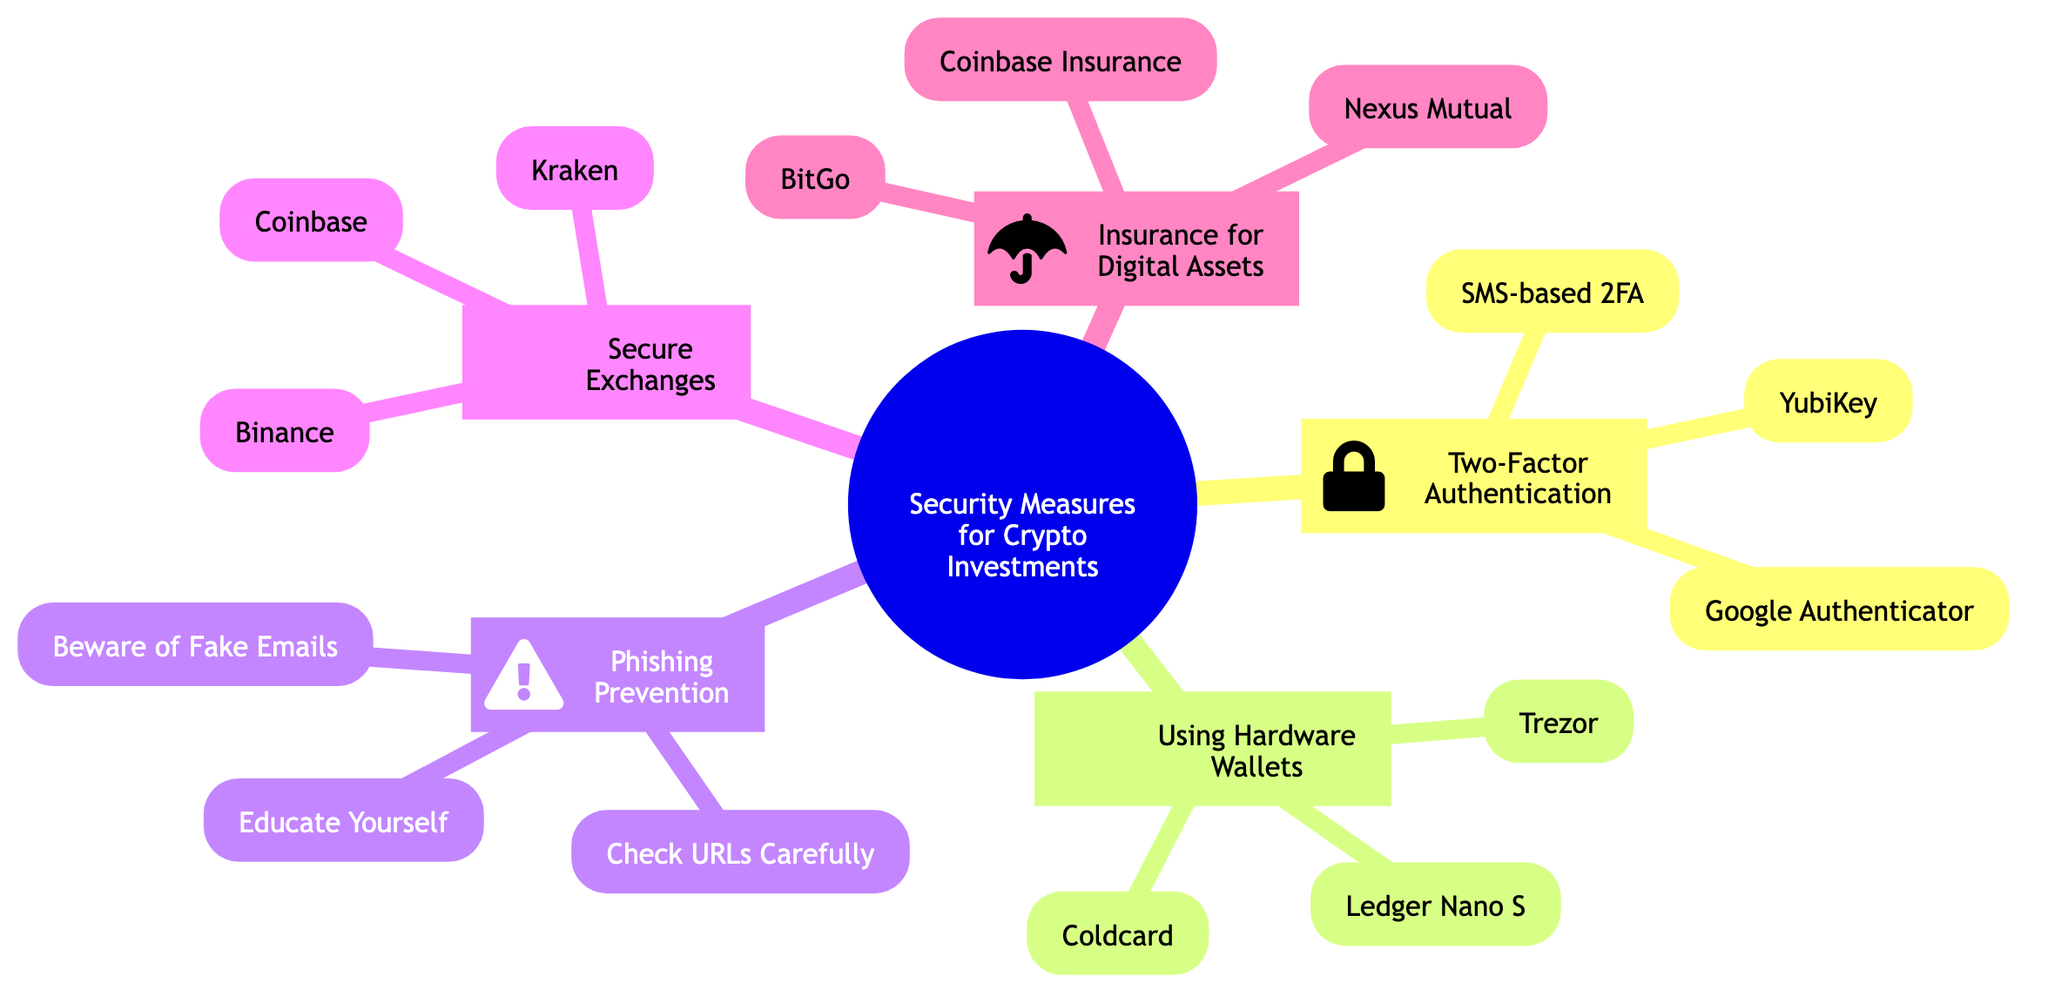What is the main topic of the mind map? The main topic is located at the root of the diagram, clearly labeled as "Security Measures for Crypto Investments." This can be directly read from the diagram, making it easy to identify.
Answer: Security Measures for Crypto Investments How many subtopics are listed under the main topic? The diagram shows five distinct subtopics branching from the main topic. Each subtopic is a separate node connected to the root node, allowing for easy counting.
Answer: 5 What type of authentication is represented by Google Authenticator? In the section "Two-Factor Authentication," Google Authenticator is specifically categorized as an app for two-step verification codes. This is noted directly under the corresponding subtopic in the diagram.
Answer: Two-step verification Which hardware wallet focuses primarily on Bitcoin? Under the "Using Hardware Wallets" subtopic, Coldcard is explicitly mentioned as focusing on Bitcoin and known for high security. This distinction is clearly noted within the provided elements.
Answer: Coldcard What security measure does Coinbase offer for insuring digital assets? In the "Insurance for Digital Assets" section, Coinbase Insurance is mentioned as providing coverage for losses from breaches up to a limit, indicating its specific role. This detail is directly stated in the diagram’s elements.
Answer: Coinbase Insurance What types of phishing prevention are suggested? The section labeled "Phishing Prevention" lists three methods: "Beware of Fake Emails," "Check URLs Carefully," and "Educate Yourself." Each method addresses a specific aspect of phishing prevention, and thus all three are considered as correct answers.
Answer: Beware of Fake Emails, Check URLs Carefully, Educate Yourself Which exchange is known for storing 98% of funds offline? Within the "Secure Exchanges" section, Coinbase is specifically noted for this practice. This information can be located near the exchange's name in the diagram, highlighting its security measures.
Answer: Coinbase What is the purpose of using hardware wallets? The "Using Hardware Wallets" subtopic describes that these wallets are used for storing cryptocurrencies offline to prevent hacking, making their purpose clear and straightforward.
Answer: Prevent hacking What feature does Binance offer for security? The diagram under the "Secure Exchanges" section highlights that Binance offers an extensive security feature called the SAFU fund. This unique feature reflects a specific commitment to user security that is distinctive to Binance.
Answer: SAFU fund 